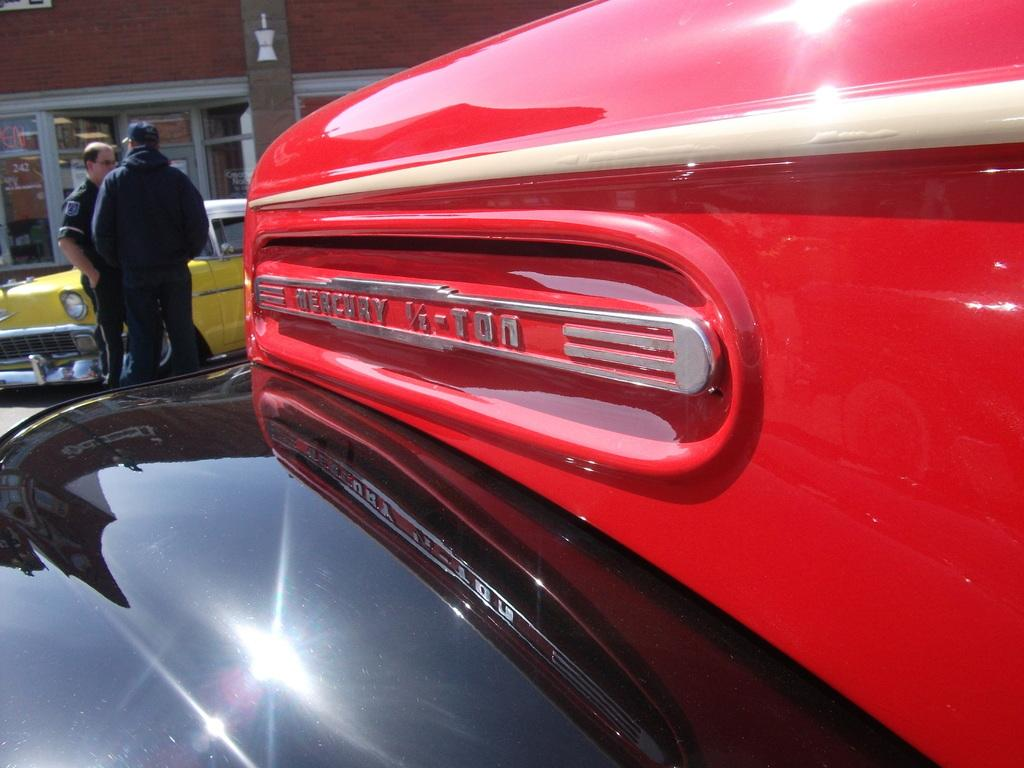<image>
Write a terse but informative summary of the picture. A side view of an an old red and black mercury truck 